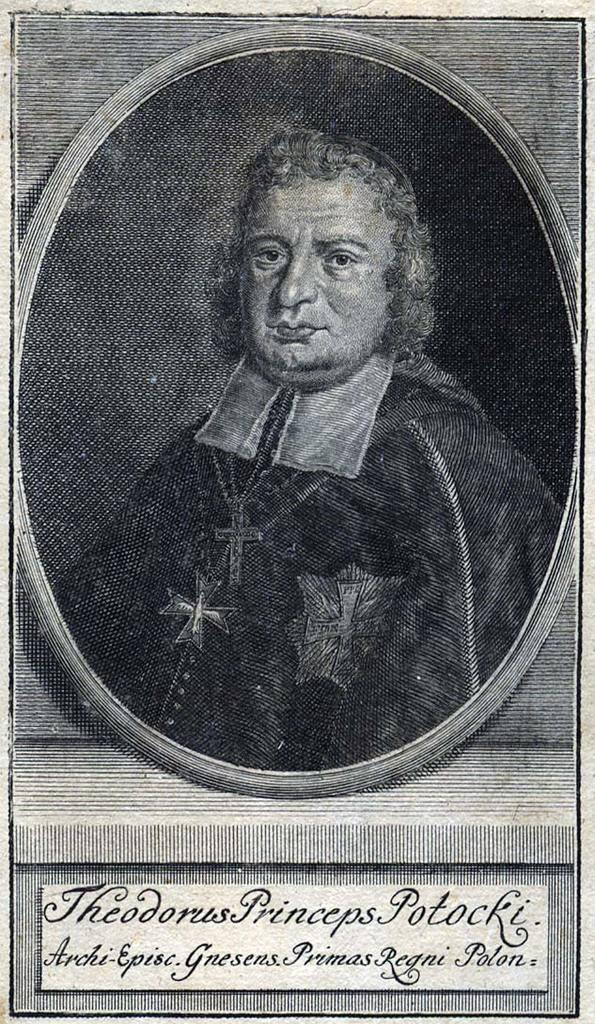What is present in the image? There is a man in the image. What is the man wearing in the image? The man is wearing a black jacket. What is the man's opinion on the soup and vegetables in the image? There is no soup or vegetables present in the image, so it is not possible to determine the man's opinion on them. 